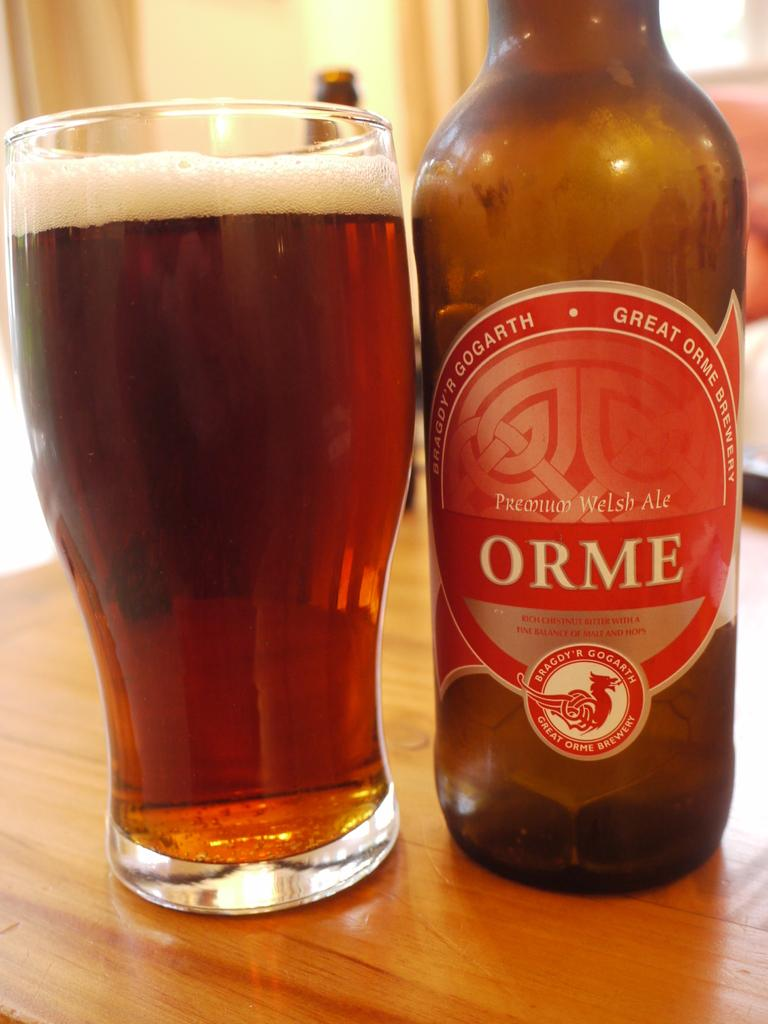<image>
Create a compact narrative representing the image presented. A bottle of Orme Premium Welsh Ale has been poured into a glass. 